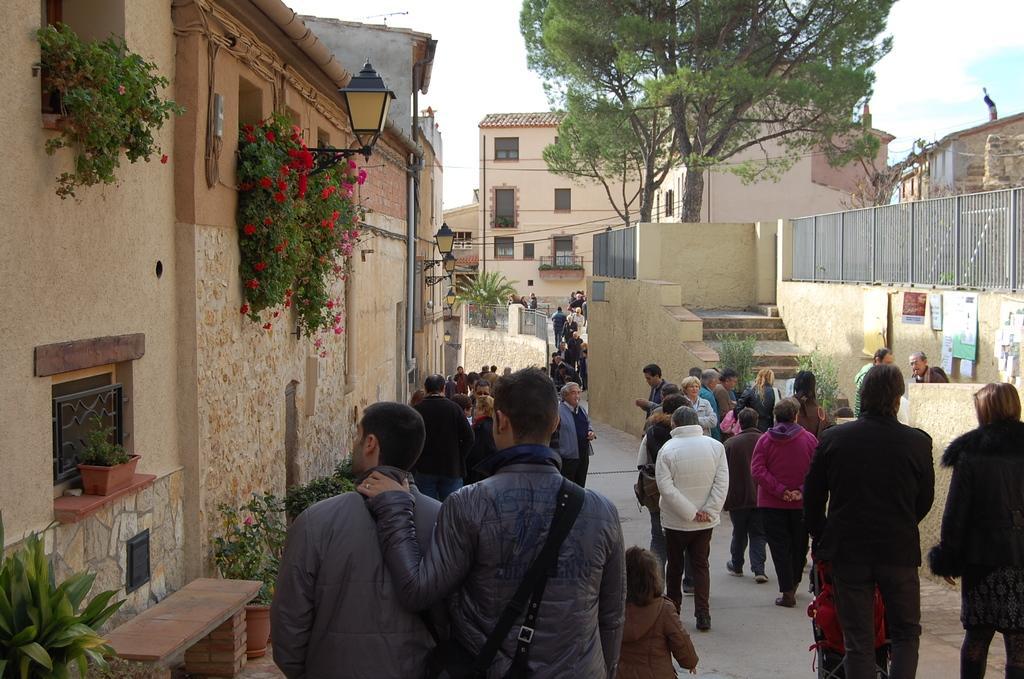Describe this image in one or two sentences. In this image I can see the group of people with different color dresses. To the left I can the building with plants and the flowertots. I can also see the lamb to the building. These flowers are in red color. To the right I can see the boards to the wall and the railing. In the background I can see the trees, few more buildings and the sky. 